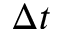<formula> <loc_0><loc_0><loc_500><loc_500>\Delta t</formula> 